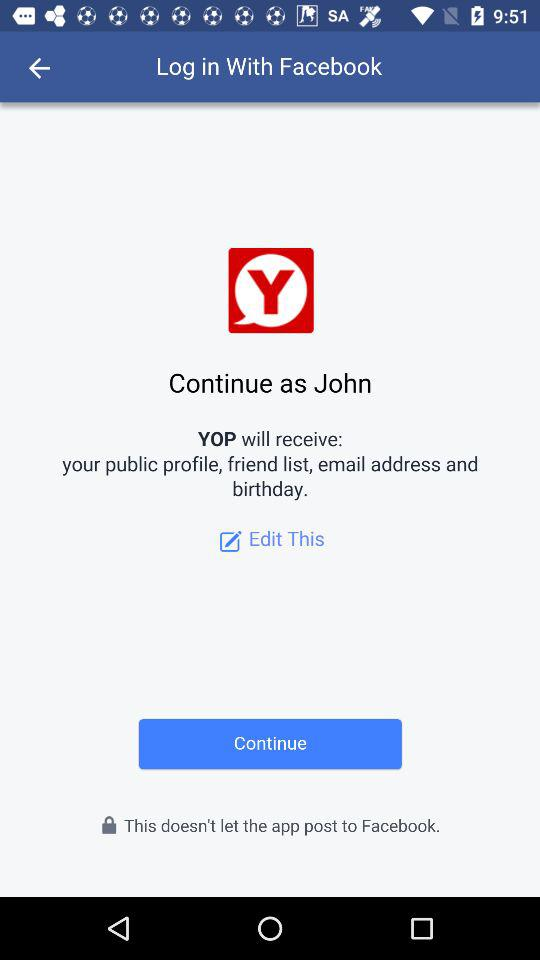What application is asking for permission? The application that is asking for permission is "YOP". 